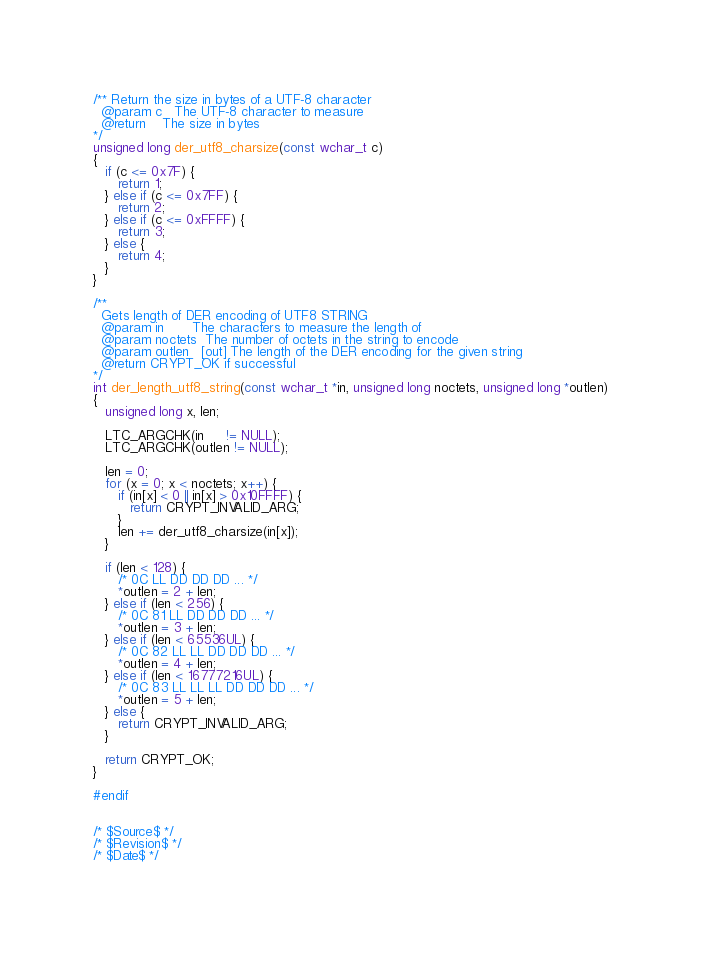Convert code to text. <code><loc_0><loc_0><loc_500><loc_500><_C_>
/** Return the size in bytes of a UTF-8 character
  @param c   The UTF-8 character to measure
  @return    The size in bytes
*/
unsigned long der_utf8_charsize(const wchar_t c)
{
   if (c <= 0x7F) {
      return 1;
   } else if (c <= 0x7FF) {
      return 2;
   } else if (c <= 0xFFFF) {
      return 3;
   } else {
      return 4;
   }
}

/**
  Gets length of DER encoding of UTF8 STRING 
  @param in       The characters to measure the length of
  @param noctets  The number of octets in the string to encode
  @param outlen   [out] The length of the DER encoding for the given string
  @return CRYPT_OK if successful
*/
int der_length_utf8_string(const wchar_t *in, unsigned long noctets, unsigned long *outlen)
{
   unsigned long x, len;

   LTC_ARGCHK(in     != NULL);
   LTC_ARGCHK(outlen != NULL);

   len = 0;
   for (x = 0; x < noctets; x++) {
      if (in[x] < 0 || in[x] > 0x10FFFF) {
         return CRYPT_INVALID_ARG;
      }
      len += der_utf8_charsize(in[x]);
   }

   if (len < 128) {
      /* 0C LL DD DD DD ... */
      *outlen = 2 + len;
   } else if (len < 256) {
      /* 0C 81 LL DD DD DD ... */
      *outlen = 3 + len;
   } else if (len < 65536UL) {
      /* 0C 82 LL LL DD DD DD ... */
      *outlen = 4 + len;
   } else if (len < 16777216UL) {
      /* 0C 83 LL LL LL DD DD DD ... */
      *outlen = 5 + len;
   } else {
      return CRYPT_INVALID_ARG;
   }

   return CRYPT_OK;
}

#endif


/* $Source$ */
/* $Revision$ */
/* $Date$ */
</code> 